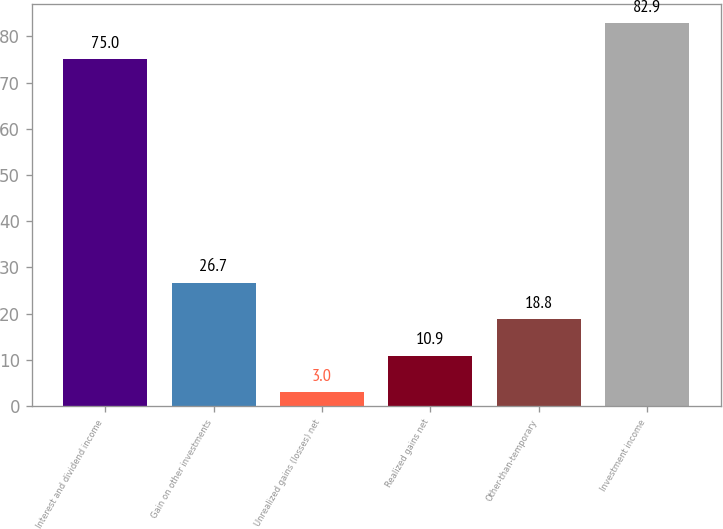Convert chart. <chart><loc_0><loc_0><loc_500><loc_500><bar_chart><fcel>Interest and dividend income<fcel>Gain on other investments<fcel>Unrealized gains (losses) net<fcel>Realized gains net<fcel>Other-than-temporary<fcel>Investment income<nl><fcel>75<fcel>26.7<fcel>3<fcel>10.9<fcel>18.8<fcel>82.9<nl></chart> 